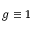Convert formula to latex. <formula><loc_0><loc_0><loc_500><loc_500>g \equiv 1</formula> 